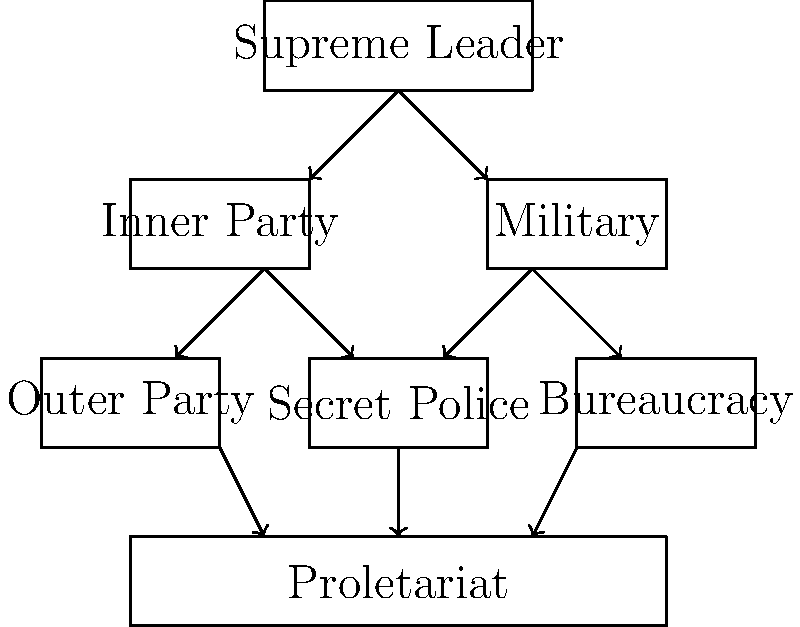In the organizational chart representing the hierarchy of control in a totalitarian state inspired by Orwell's works, how many levels of power exist between the Supreme Leader and the Proletariat? To determine the number of levels between the Supreme Leader and the Proletariat, we need to count the distinct layers in the organizational chart:

1. At the top, we have the Supreme Leader.
2. Below the Supreme Leader, we see the Inner Party and Military on the same level.
3. The next level down consists of the Outer Party, Secret Police, and Bureaucracy.
4. At the bottom, we have the Proletariat.

To calculate the number of levels between the Supreme Leader and the Proletariat:

1. Start with the total number of levels: 4
2. Subtract 1 to exclude the Supreme Leader's level
3. Subtract 1 to exclude the Proletariat's level

Therefore, the number of levels between the Supreme Leader and the Proletariat is:

$$ 4 - 1 - 1 = 2 $$

This hierarchical structure reflects the concentration of power at the top and the oppression of the masses at the bottom, which is a key characteristic of totalitarian regimes as described in Orwell's works.
Answer: 2 levels 